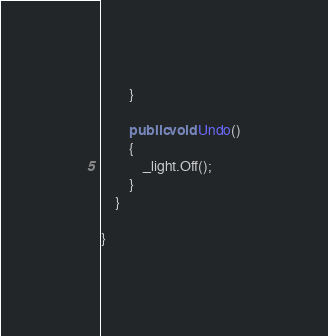<code> <loc_0><loc_0><loc_500><loc_500><_C#_>        }

        public void Undo()
        {
            _light.Off();
        }
    }

}
</code> 